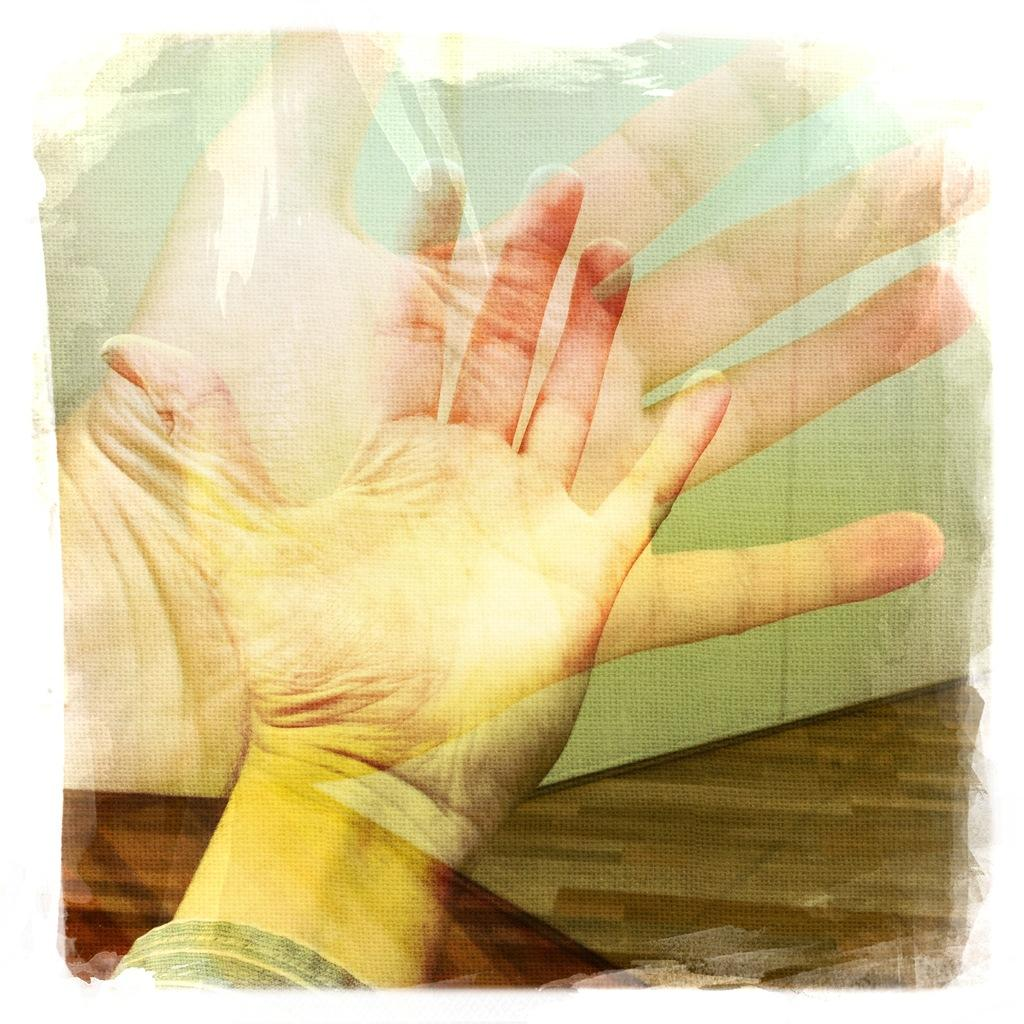What can be observed about the image's appearance? The image appears to be edited. What body part is visible in the image? There are person's hands visible in the image. How does the person in the image draw attention to themselves? There is no indication in the image of how the person might draw attention to themselves, as only their hands are visible. 